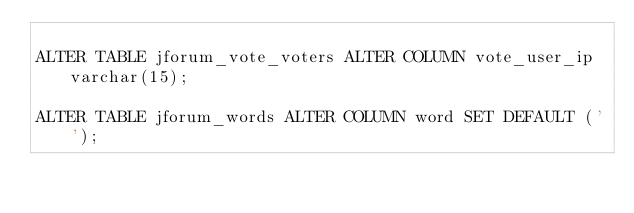Convert code to text. <code><loc_0><loc_0><loc_500><loc_500><_SQL_>
ALTER TABLE jforum_vote_voters ALTER COLUMN vote_user_ip varchar(15);

ALTER TABLE jforum_words ALTER COLUMN word SET DEFAULT ('');</code> 